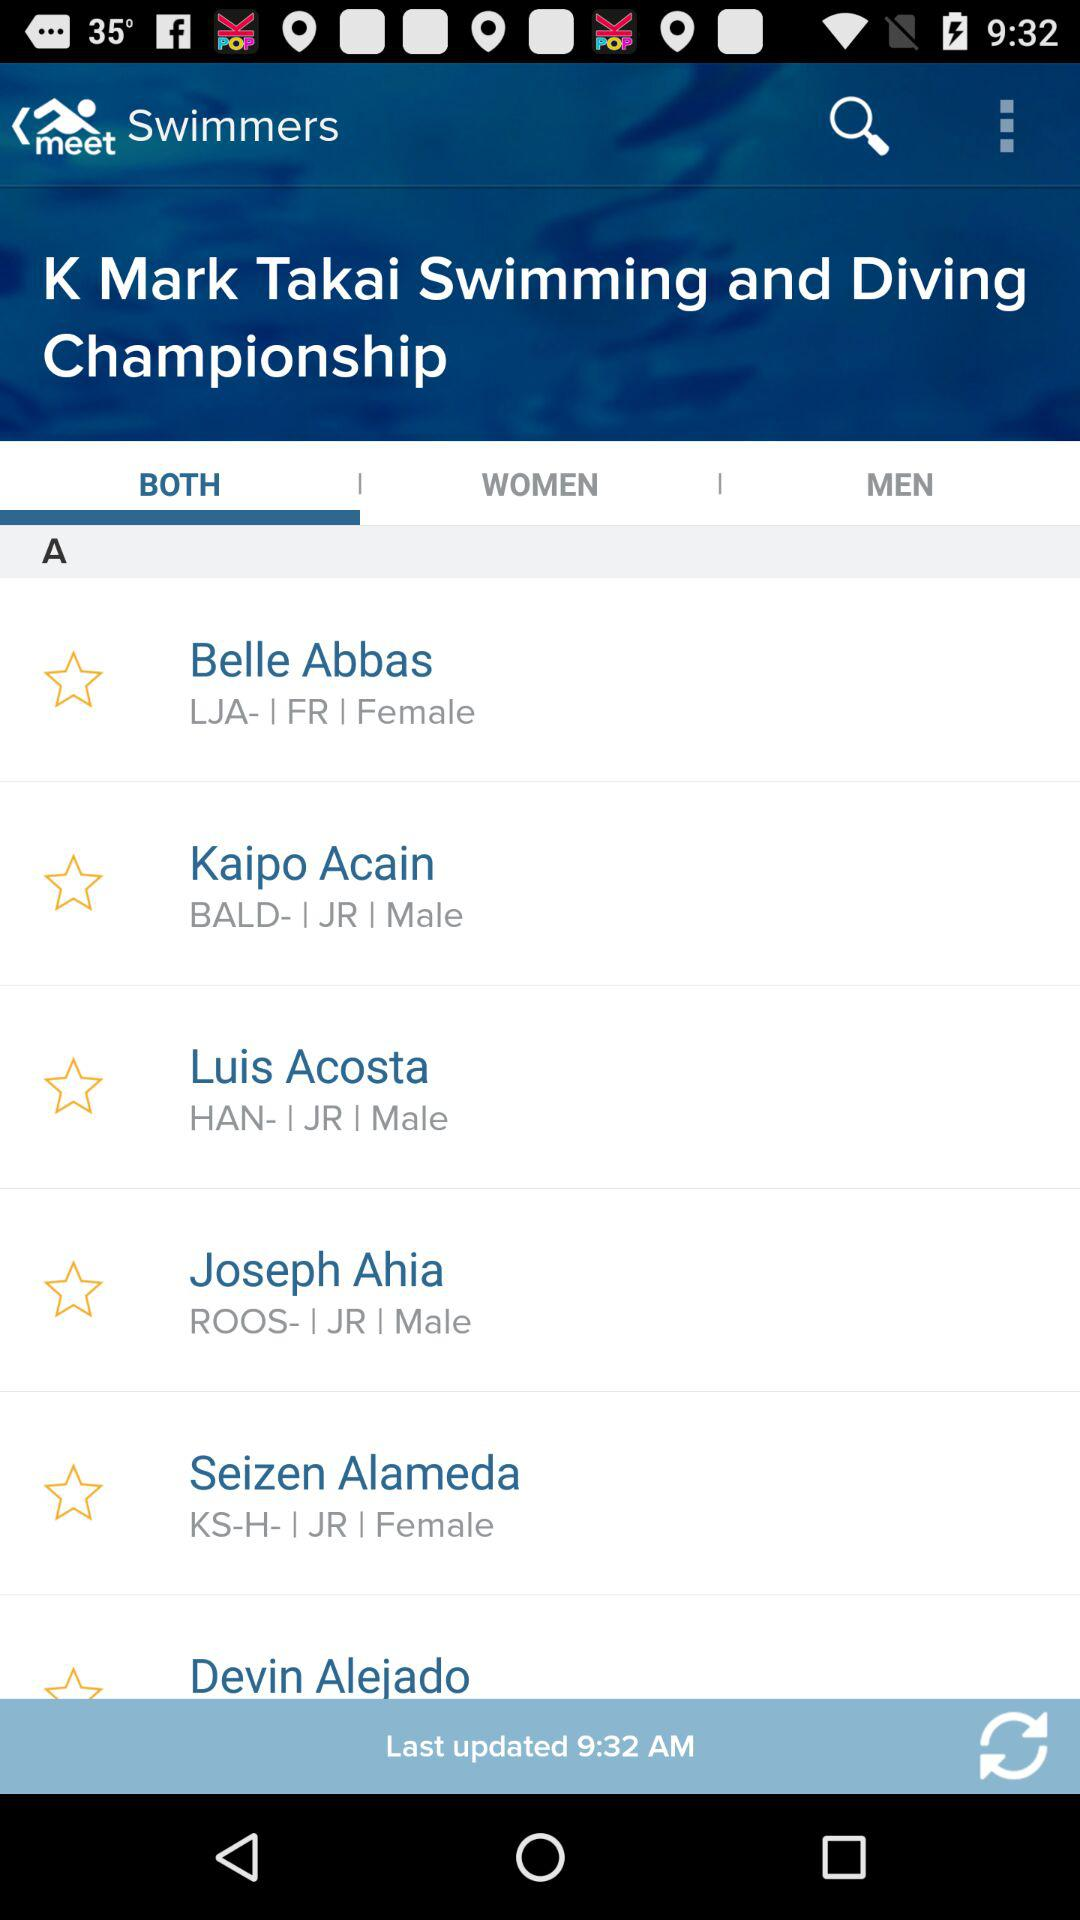Which tab is selected? The selected tab is "BOTH". 